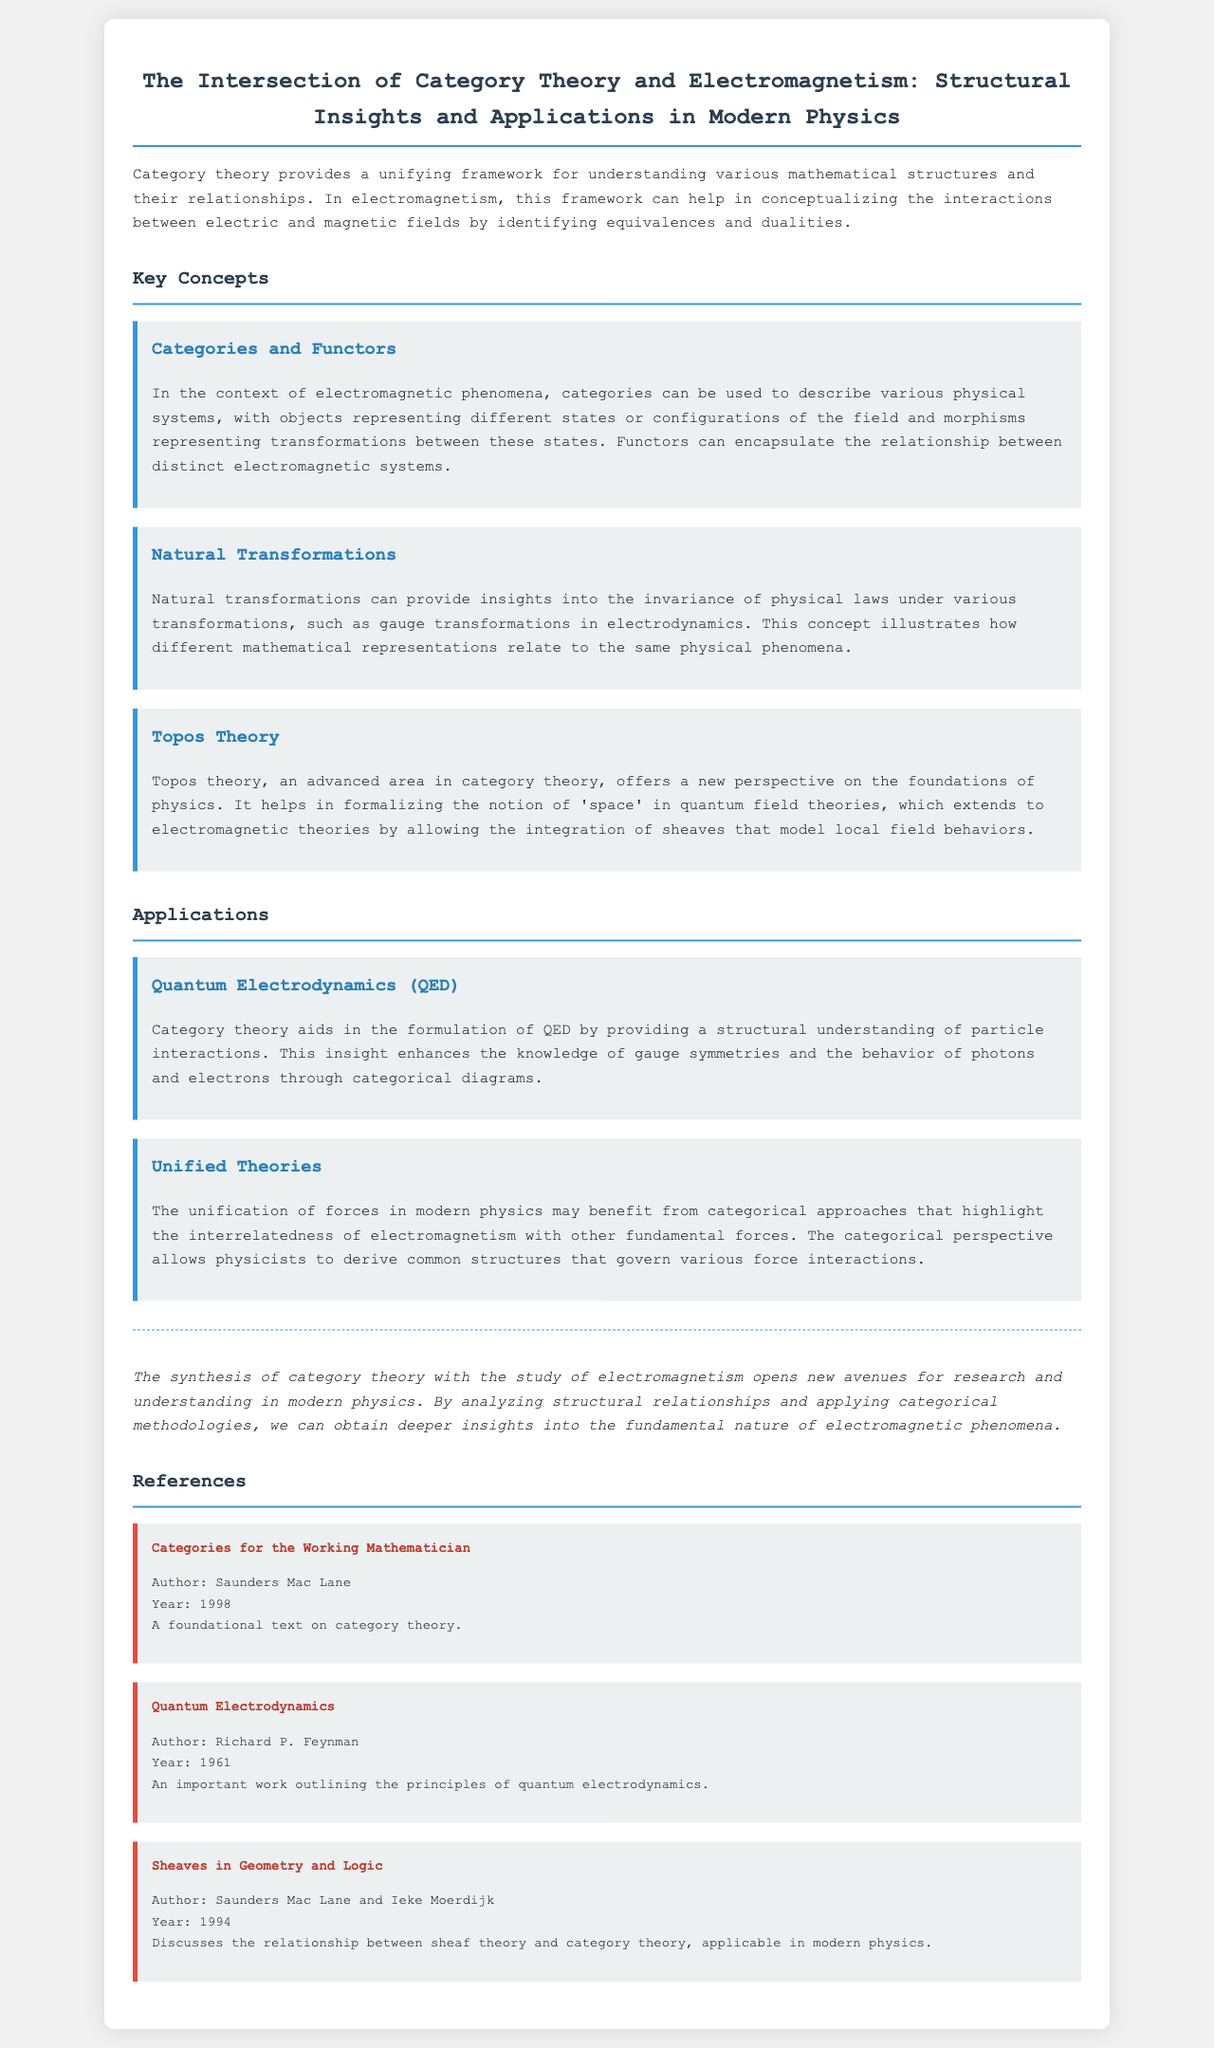What is the title of the document? The title is explicitly stated at the beginning of the document, emphasizing the focus of the report.
Answer: The Intersection of Category Theory and Electromagnetism: Structural Insights and Applications in Modern Physics Who is the author of "Categories for the Working Mathematician"? The reference section lists authors and their works, making it easy to identify who wrote the mentioned text.
Answer: Saunders Mac Lane In what year was "Quantum Electrodynamics" published? The document provides publication years for the referenced works, allowing for quick retrieval of such information.
Answer: 1961 What advanced area in category theory is mentioned in the document? The key concepts section discusses areas of category theory, including advanced topics important in physics.
Answer: Topos Theory How does category theory aid in Quantum Electrodynamics? The applications section outlines how category theory contributes to the understanding of QED and its implications in physical interactions.
Answer: Provides a structural understanding What does the synthesis of category theory with electromagnetism open? The conclusion section summarizes the potential impact of integrating category theory with electromagnetism, highlighting future prospects.
Answer: New avenues for research What type of transformations do natural transformations illustrate? The explanation of natural transformations discusses aspects relevant to physical laws and their mathematical representations.
Answer: Gauge transformations What is the common connection highlighted in unified theories? The applications section presents the idea of interrelatedness among fundamental forces, emphasizing the connections derived from categorical perspectives.
Answer: Interrelatedness of electromagnetism with other fundamental forces 